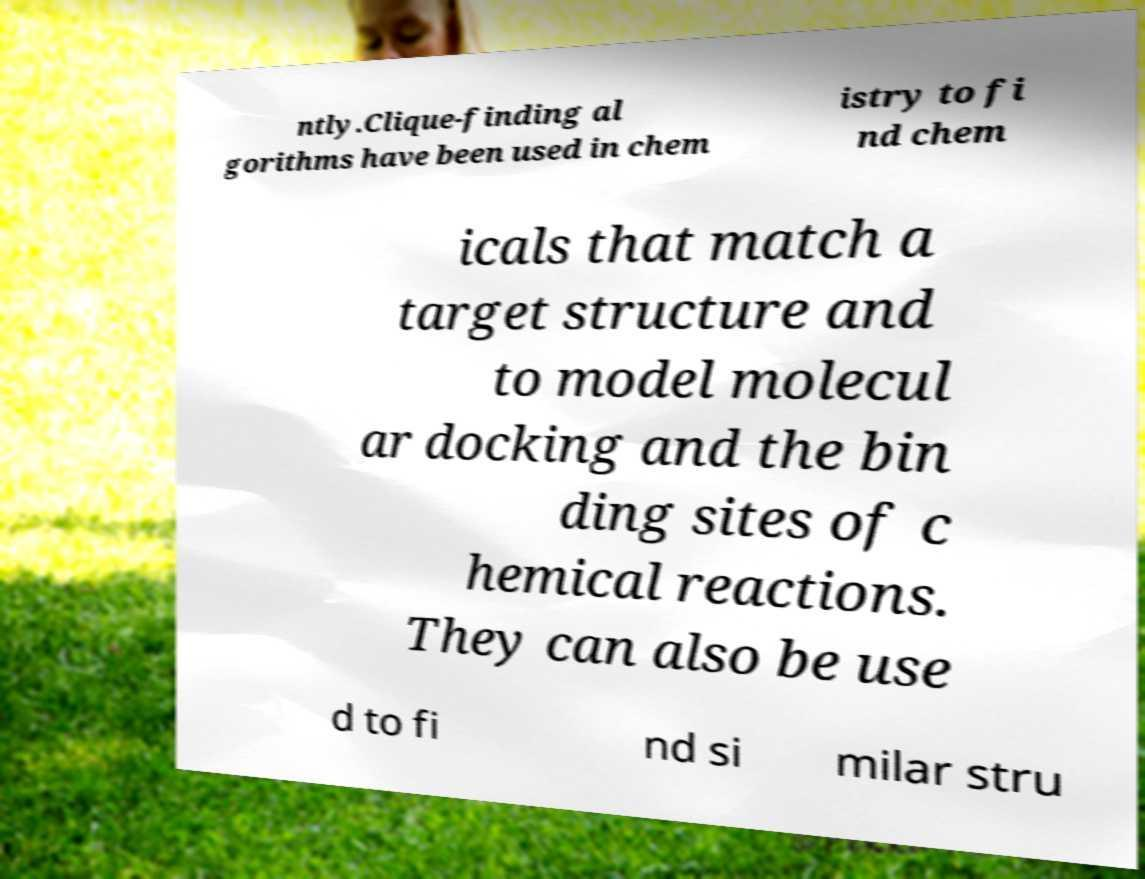Please identify and transcribe the text found in this image. ntly.Clique-finding al gorithms have been used in chem istry to fi nd chem icals that match a target structure and to model molecul ar docking and the bin ding sites of c hemical reactions. They can also be use d to fi nd si milar stru 